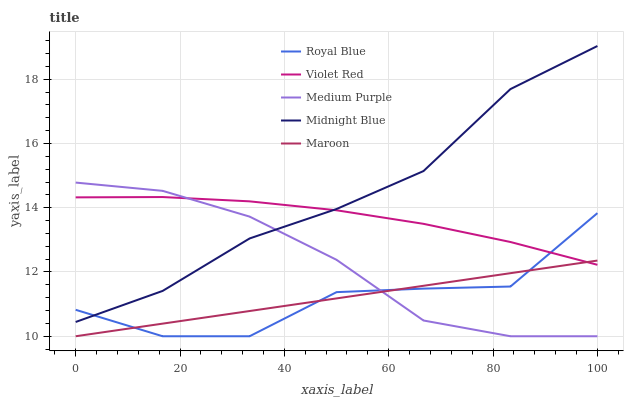Does Royal Blue have the minimum area under the curve?
Answer yes or no. Yes. Does Midnight Blue have the maximum area under the curve?
Answer yes or no. Yes. Does Violet Red have the minimum area under the curve?
Answer yes or no. No. Does Violet Red have the maximum area under the curve?
Answer yes or no. No. Is Maroon the smoothest?
Answer yes or no. Yes. Is Royal Blue the roughest?
Answer yes or no. Yes. Is Violet Red the smoothest?
Answer yes or no. No. Is Violet Red the roughest?
Answer yes or no. No. Does Medium Purple have the lowest value?
Answer yes or no. Yes. Does Violet Red have the lowest value?
Answer yes or no. No. Does Midnight Blue have the highest value?
Answer yes or no. Yes. Does Royal Blue have the highest value?
Answer yes or no. No. Is Maroon less than Midnight Blue?
Answer yes or no. Yes. Is Midnight Blue greater than Maroon?
Answer yes or no. Yes. Does Midnight Blue intersect Royal Blue?
Answer yes or no. Yes. Is Midnight Blue less than Royal Blue?
Answer yes or no. No. Is Midnight Blue greater than Royal Blue?
Answer yes or no. No. Does Maroon intersect Midnight Blue?
Answer yes or no. No. 